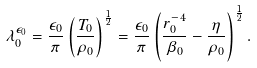<formula> <loc_0><loc_0><loc_500><loc_500>\lambda _ { 0 } ^ { \epsilon _ { 0 } } = \frac { \epsilon _ { 0 } } { \pi } \left ( \frac { T _ { 0 } } { \rho _ { 0 } } \right ) ^ { \frac { 1 } { 2 } } = \frac { \epsilon _ { 0 } } { \pi } \left ( \frac { r _ { 0 } ^ { - 4 } } { \beta _ { 0 } } - \frac { \eta } { \rho _ { 0 } } \right ) ^ { \frac { 1 } { 2 } } .</formula> 